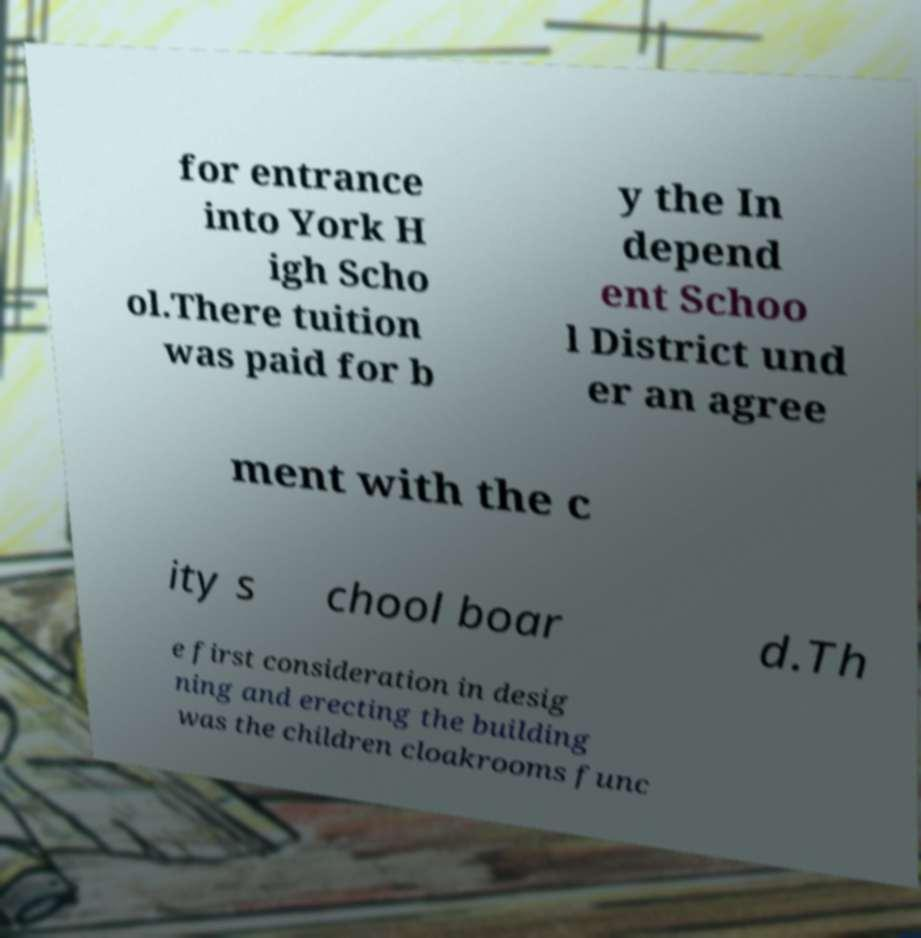Please identify and transcribe the text found in this image. for entrance into York H igh Scho ol.There tuition was paid for b y the In depend ent Schoo l District und er an agree ment with the c ity s chool boar d.Th e first consideration in desig ning and erecting the building was the children cloakrooms func 